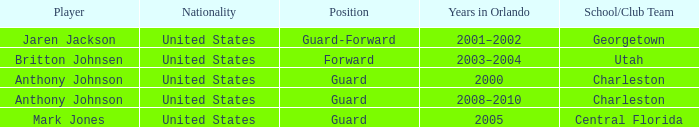What was the Position of the Player, Britton Johnsen? Forward. 